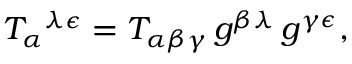<formula> <loc_0><loc_0><loc_500><loc_500>T _ { \alpha ^ { \lambda \epsilon } = T _ { \alpha \beta \gamma } \, g ^ { \beta \lambda } \, g ^ { \gamma \epsilon } ,</formula> 